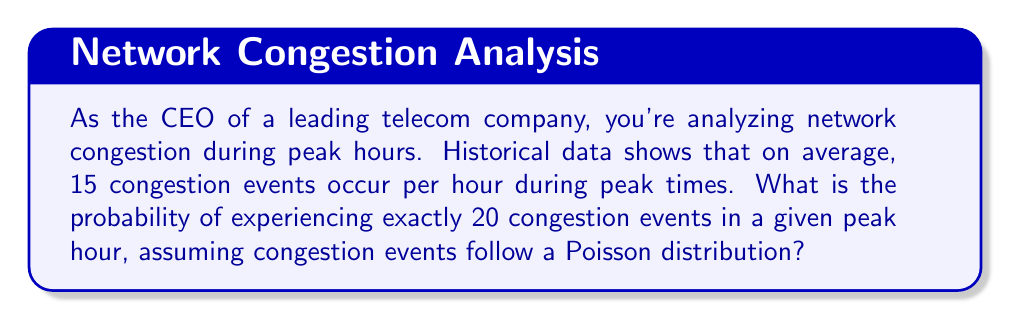Could you help me with this problem? To solve this problem, we'll use the Poisson distribution formula:

$$P(X = k) = \frac{e^{-\lambda} \lambda^k}{k!}$$

Where:
$\lambda$ = average number of events per interval
$k$ = number of events we're calculating the probability for
$e$ = Euler's number (approximately 2.71828)

Given:
$\lambda = 15$ (average congestion events per hour)
$k = 20$ (exact number of congestion events we're interested in)

Step 1: Plug the values into the Poisson distribution formula:

$$P(X = 20) = \frac{e^{-15} 15^{20}}{20!}$$

Step 2: Calculate $e^{-15}$:
$$e^{-15} \approx 3.059 \times 10^{-7}$$

Step 3: Calculate $15^{20}$:
$$15^{20} \approx 3.269 \times 10^{23}$$

Step 4: Calculate $20!$:
$$20! = 2.433 \times 10^{18}$$

Step 5: Combine all parts and calculate the final probability:

$$P(X = 20) = \frac{(3.059 \times 10^{-7})(3.269 \times 10^{23})}{2.433 \times 10^{18}} \approx 0.0409$$

Step 6: Convert to percentage:
$$0.0409 \times 100\% = 4.09\%$$
Answer: 4.09% 